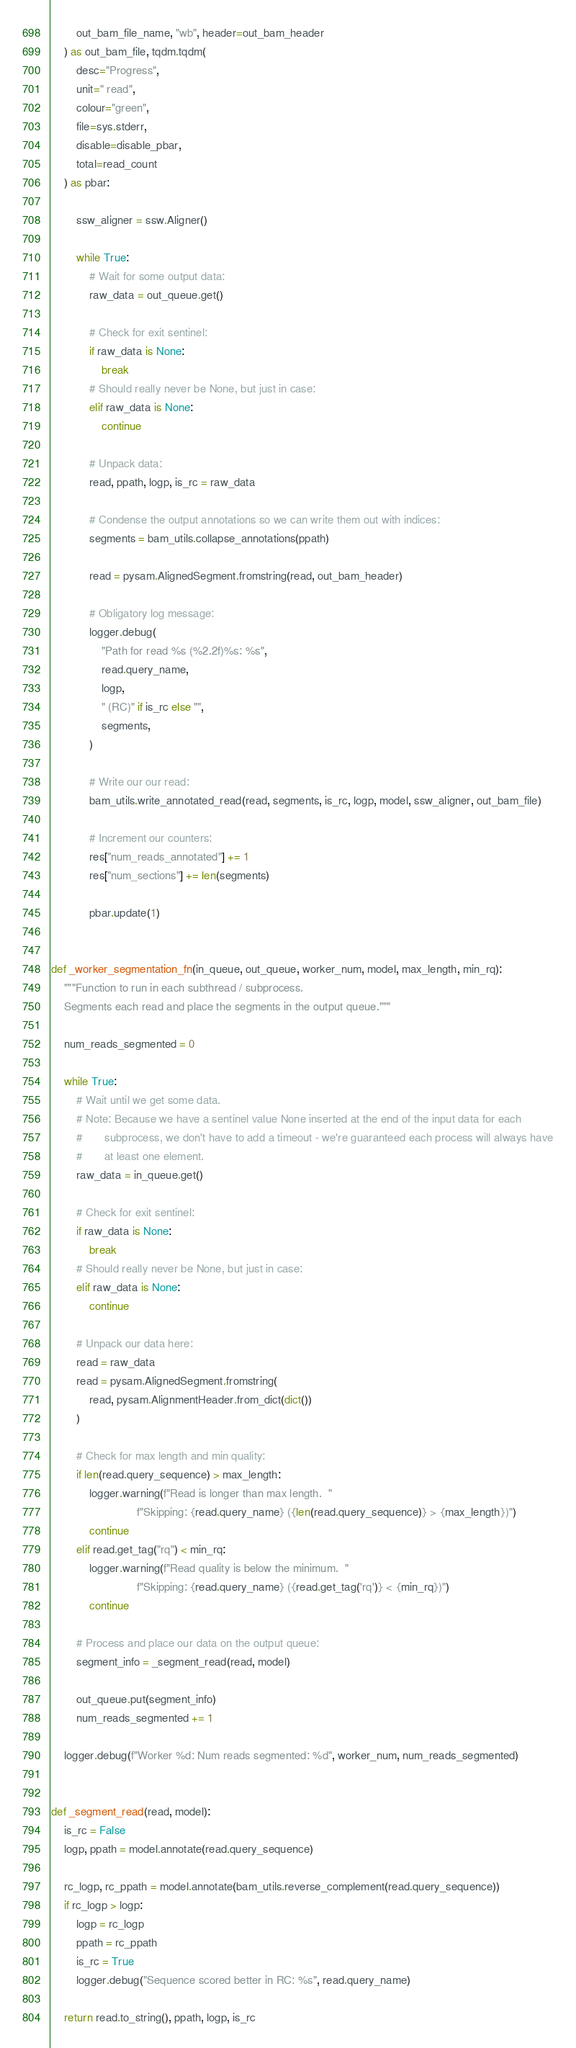<code> <loc_0><loc_0><loc_500><loc_500><_Python_>        out_bam_file_name, "wb", header=out_bam_header
    ) as out_bam_file, tqdm.tqdm(
        desc="Progress",
        unit=" read",
        colour="green",
        file=sys.stderr,
        disable=disable_pbar,
        total=read_count
    ) as pbar:

        ssw_aligner = ssw.Aligner()

        while True:
            # Wait for some output data:
            raw_data = out_queue.get()

            # Check for exit sentinel:
            if raw_data is None:
                break
            # Should really never be None, but just in case:
            elif raw_data is None:
                continue

            # Unpack data:
            read, ppath, logp, is_rc = raw_data

            # Condense the output annotations so we can write them out with indices:
            segments = bam_utils.collapse_annotations(ppath)

            read = pysam.AlignedSegment.fromstring(read, out_bam_header)

            # Obligatory log message:
            logger.debug(
                "Path for read %s (%2.2f)%s: %s",
                read.query_name,
                logp,
                " (RC)" if is_rc else "",
                segments,
            )

            # Write our our read:
            bam_utils.write_annotated_read(read, segments, is_rc, logp, model, ssw_aligner, out_bam_file)

            # Increment our counters:
            res["num_reads_annotated"] += 1
            res["num_sections"] += len(segments)

            pbar.update(1)


def _worker_segmentation_fn(in_queue, out_queue, worker_num, model, max_length, min_rq):
    """Function to run in each subthread / subprocess.
    Segments each read and place the segments in the output queue."""

    num_reads_segmented = 0

    while True:
        # Wait until we get some data.
        # Note: Because we have a sentinel value None inserted at the end of the input data for each
        #       subprocess, we don't have to add a timeout - we're guaranteed each process will always have
        #       at least one element.
        raw_data = in_queue.get()

        # Check for exit sentinel:
        if raw_data is None:
            break
        # Should really never be None, but just in case:
        elif raw_data is None:
            continue

        # Unpack our data here:
        read = raw_data
        read = pysam.AlignedSegment.fromstring(
            read, pysam.AlignmentHeader.from_dict(dict())
        )

        # Check for max length and min quality:
        if len(read.query_sequence) > max_length:
            logger.warning(f"Read is longer than max length.  "
                           f"Skipping: {read.query_name} ({len(read.query_sequence)} > {max_length})")
            continue
        elif read.get_tag("rq") < min_rq:
            logger.warning(f"Read quality is below the minimum.  "
                           f"Skipping: {read.query_name} ({read.get_tag('rq')} < {min_rq})")
            continue

        # Process and place our data on the output queue:
        segment_info = _segment_read(read, model)

        out_queue.put(segment_info)
        num_reads_segmented += 1

    logger.debug(f"Worker %d: Num reads segmented: %d", worker_num, num_reads_segmented)


def _segment_read(read, model):
    is_rc = False
    logp, ppath = model.annotate(read.query_sequence)

    rc_logp, rc_ppath = model.annotate(bam_utils.reverse_complement(read.query_sequence))
    if rc_logp > logp:
        logp = rc_logp
        ppath = rc_ppath
        is_rc = True
        logger.debug("Sequence scored better in RC: %s", read.query_name)

    return read.to_string(), ppath, logp, is_rc
</code> 